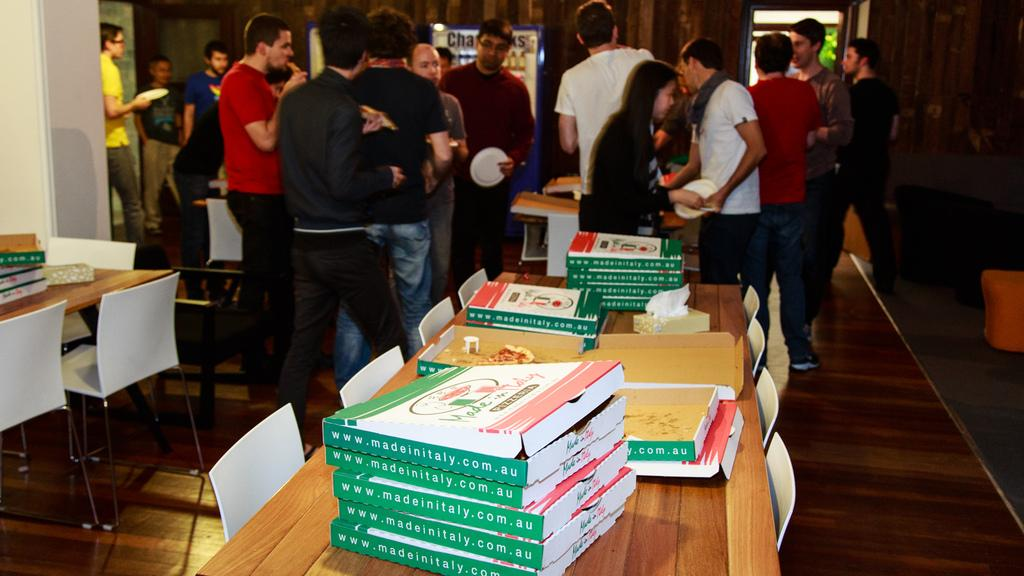What are the people in the image doing? The people in the image are standing. What objects are on the table in the image? There are boxes and pizza on the table. What furniture is present around the tables in the image? Chairs are present around the tables. What type of animal can be seen playing with the pizza in the image? There is no animal present in the image, and therefore no such activity can be observed. 